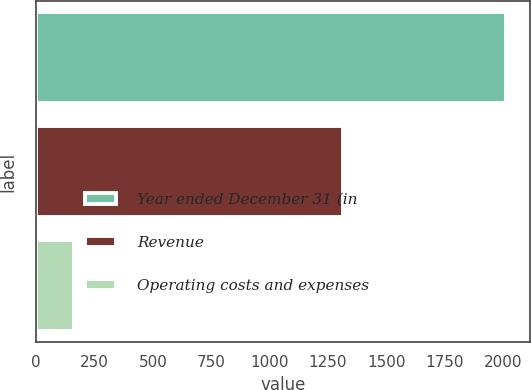<chart> <loc_0><loc_0><loc_500><loc_500><bar_chart><fcel>Year ended December 31 (in<fcel>Revenue<fcel>Operating costs and expenses<nl><fcel>2014<fcel>1315<fcel>162<nl></chart> 